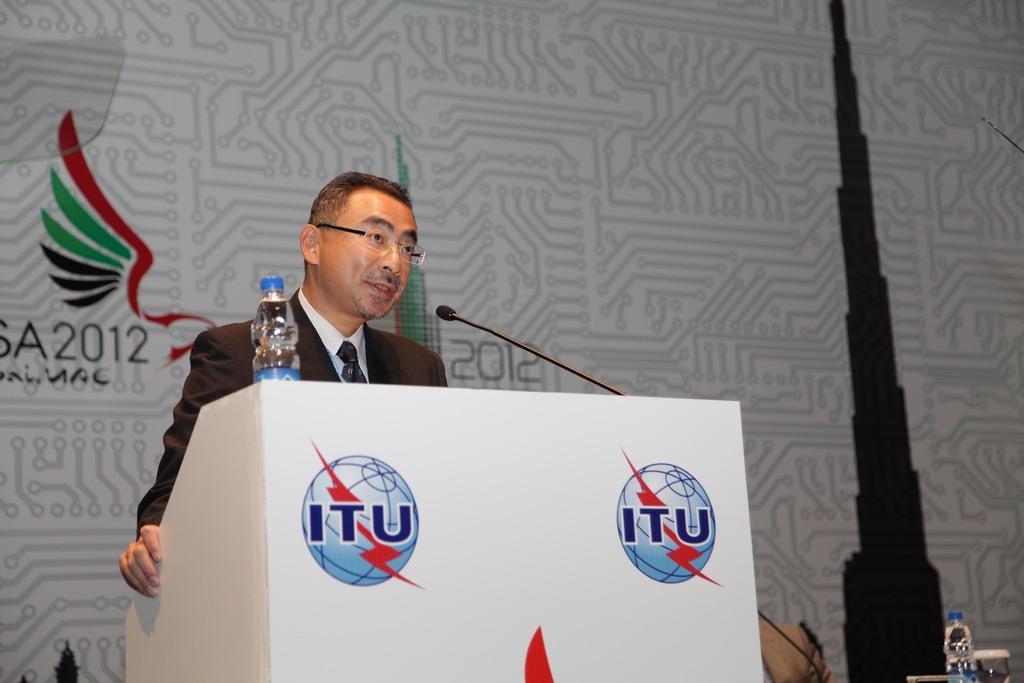Could you give a brief overview of what you see in this image? In this image I can see there is a man standing behind the podium, there is a water bottle and a microphone attached to the podium. There is a banner in the background and there is a logo on it. 